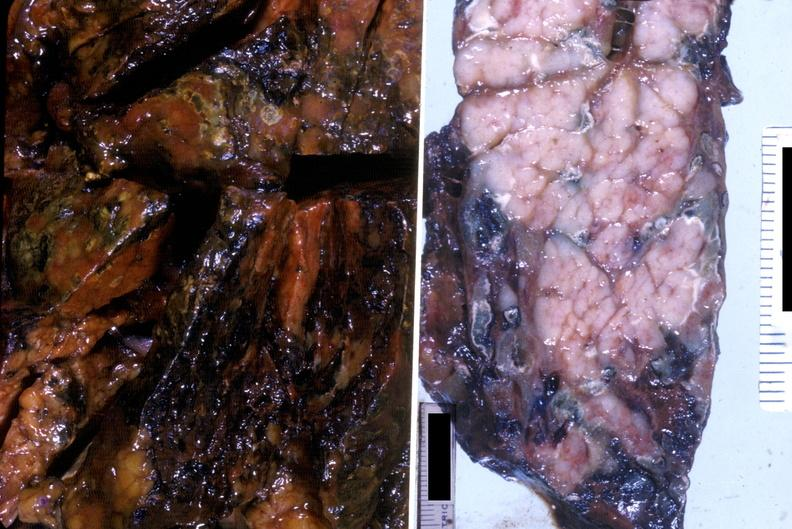does atrophy show acute hemorrhagic pancreatitis?
Answer the question using a single word or phrase. No 